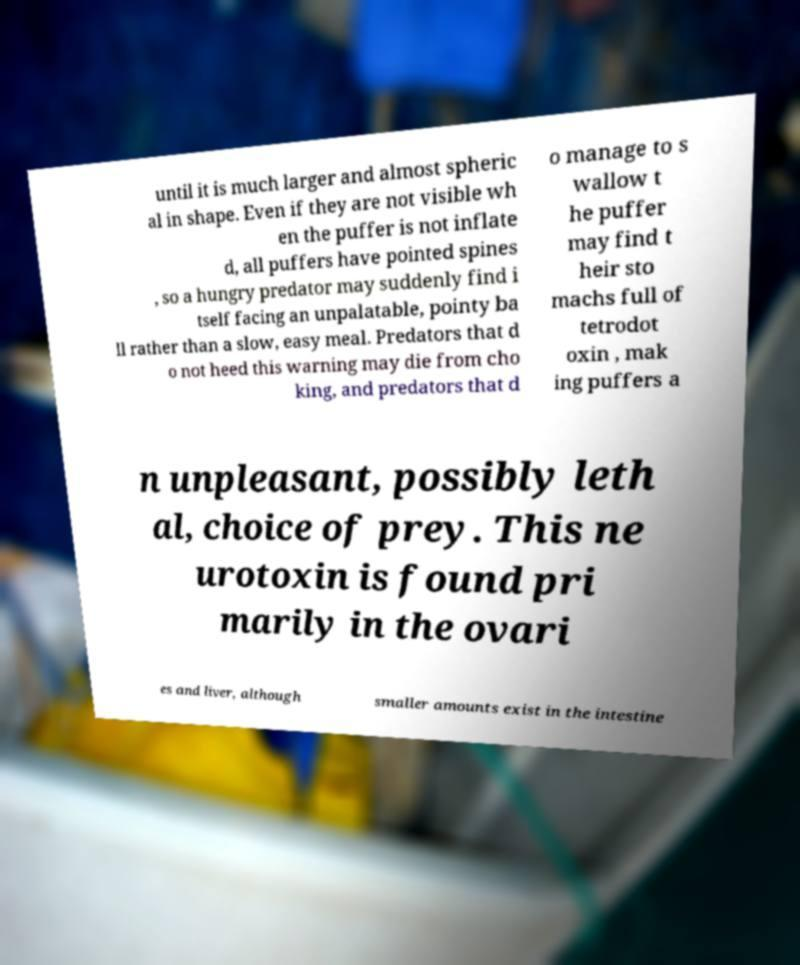Can you read and provide the text displayed in the image?This photo seems to have some interesting text. Can you extract and type it out for me? until it is much larger and almost spheric al in shape. Even if they are not visible wh en the puffer is not inflate d, all puffers have pointed spines , so a hungry predator may suddenly find i tself facing an unpalatable, pointy ba ll rather than a slow, easy meal. Predators that d o not heed this warning may die from cho king, and predators that d o manage to s wallow t he puffer may find t heir sto machs full of tetrodot oxin , mak ing puffers a n unpleasant, possibly leth al, choice of prey. This ne urotoxin is found pri marily in the ovari es and liver, although smaller amounts exist in the intestine 